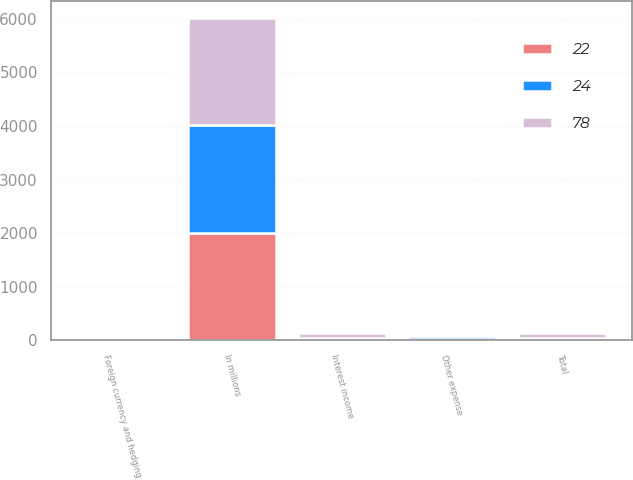<chart> <loc_0><loc_0><loc_500><loc_500><stacked_bar_chart><ecel><fcel>In millions<fcel>Interest income<fcel>Foreign currency and hedging<fcel>Other expense<fcel>Total<nl><fcel>24<fcel>2010<fcel>20<fcel>2<fcel>44<fcel>22<nl><fcel>22<fcel>2009<fcel>19<fcel>32<fcel>27<fcel>24<nl><fcel>78<fcel>2008<fcel>85<fcel>5<fcel>12<fcel>78<nl></chart> 